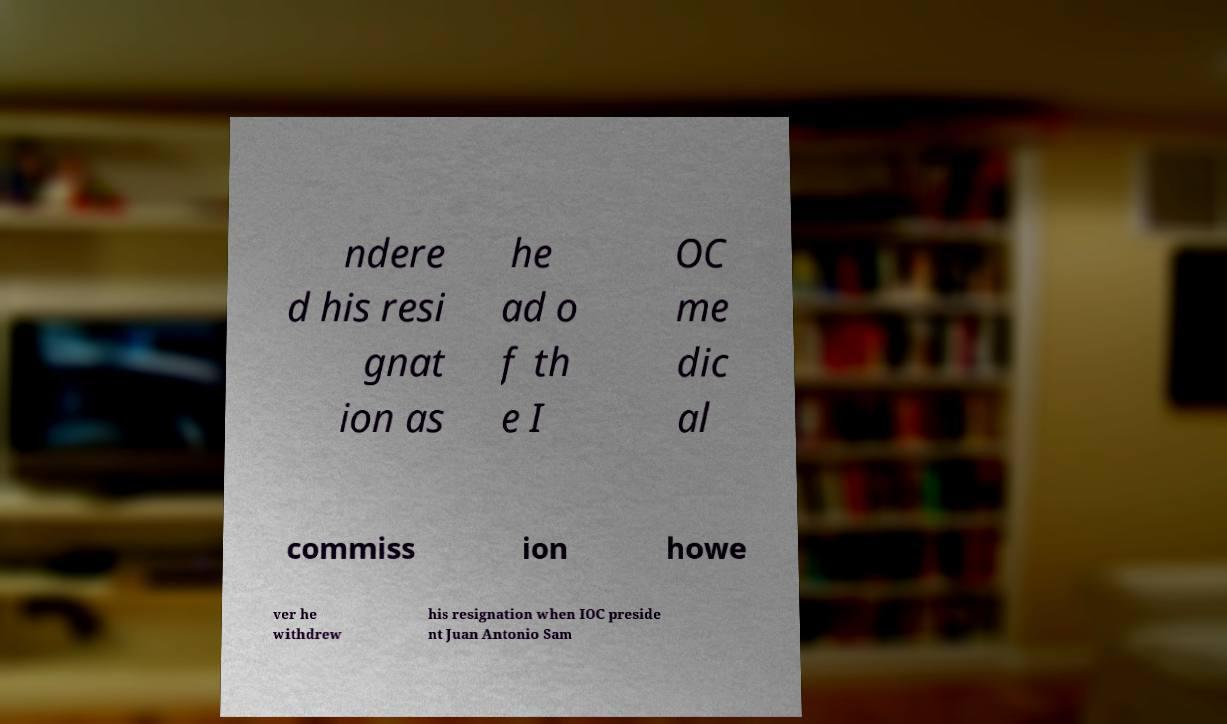There's text embedded in this image that I need extracted. Can you transcribe it verbatim? ndere d his resi gnat ion as he ad o f th e I OC me dic al commiss ion howe ver he withdrew his resignation when IOC preside nt Juan Antonio Sam 